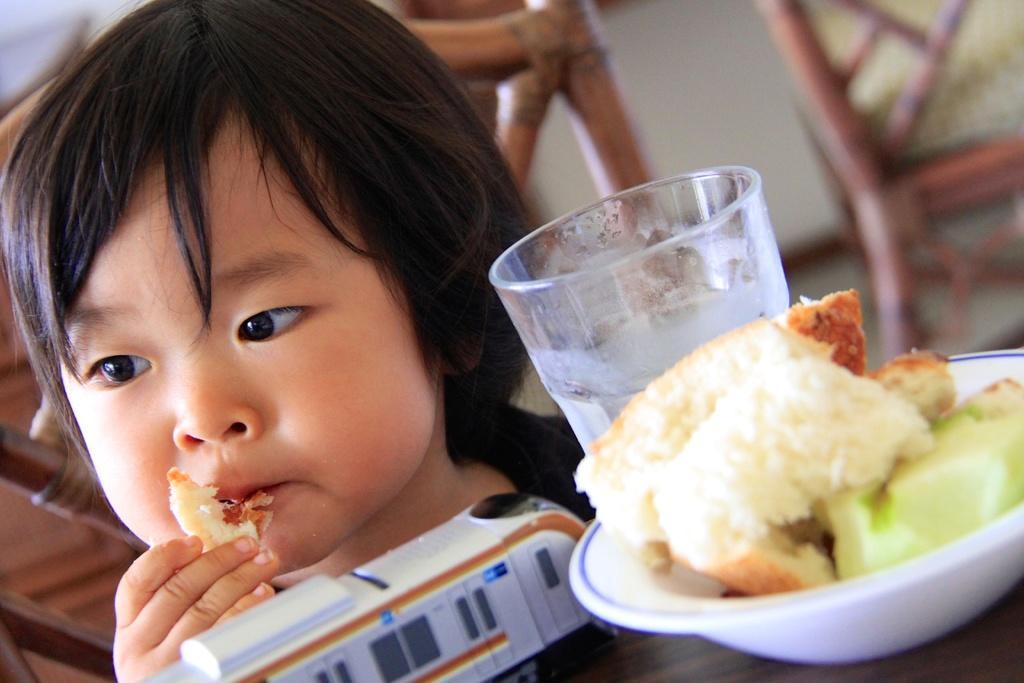Describe this image in one or two sentences. In this image we can see a child holding some food. We can also see a table beside her containing a toy, glass and some food in a plate which are placed on it. On the backside we can see some chairs and a wall. 